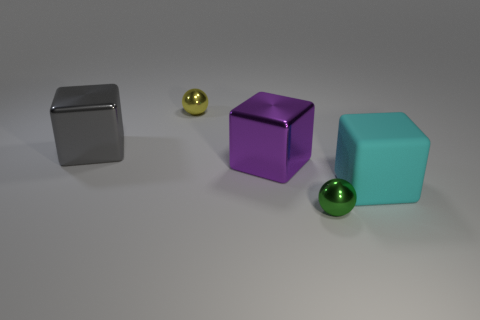What number of other things are there of the same shape as the large cyan rubber object?
Give a very brief answer. 2. What is the shape of the object that is behind the purple cube and to the right of the gray thing?
Ensure brevity in your answer.  Sphere. There is a sphere that is right of the yellow ball; what size is it?
Your answer should be very brief. Small. Is the size of the matte block the same as the green sphere?
Make the answer very short. No. Are there fewer cyan things that are behind the large purple metallic object than green shiny things behind the large gray block?
Offer a terse response. No. What size is the shiny thing that is both behind the purple block and in front of the tiny yellow thing?
Give a very brief answer. Large. There is a tiny ball in front of the shiny cube that is to the left of the purple cube; is there a green metallic object behind it?
Keep it short and to the point. No. Are there any big blue rubber cylinders?
Ensure brevity in your answer.  No. Is the number of spheres behind the tiny yellow metal sphere greater than the number of shiny objects in front of the green shiny thing?
Ensure brevity in your answer.  No. What size is the green thing that is made of the same material as the purple object?
Offer a very short reply. Small. 